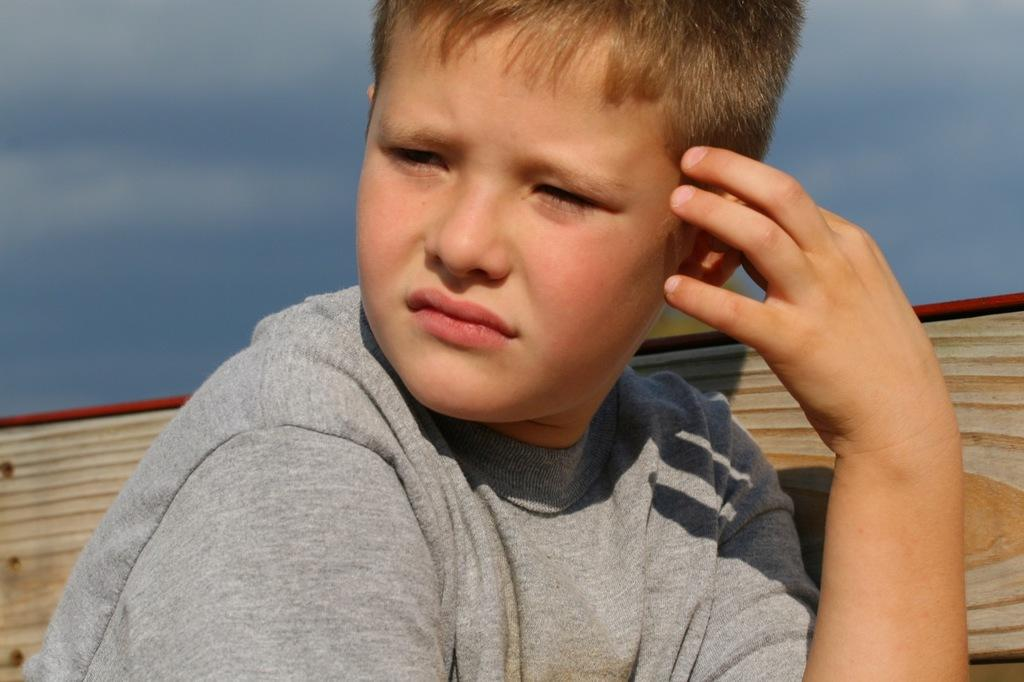What is the main subject of the image? There is a picture of a boy in the image. Can you describe the background of the boy? The background of the boy is blurred. How many rabbits are hiding behind the boy's legs in the image? There are no rabbits present in the image, and the boy's legs are not visible. 